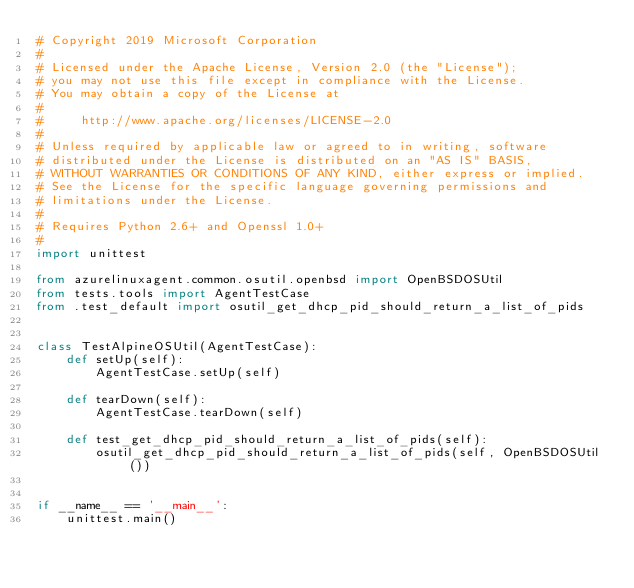<code> <loc_0><loc_0><loc_500><loc_500><_Python_># Copyright 2019 Microsoft Corporation
#
# Licensed under the Apache License, Version 2.0 (the "License");
# you may not use this file except in compliance with the License.
# You may obtain a copy of the License at
#
#     http://www.apache.org/licenses/LICENSE-2.0
#
# Unless required by applicable law or agreed to in writing, software
# distributed under the License is distributed on an "AS IS" BASIS,
# WITHOUT WARRANTIES OR CONDITIONS OF ANY KIND, either express or implied.
# See the License for the specific language governing permissions and
# limitations under the License.
#
# Requires Python 2.6+ and Openssl 1.0+
#
import unittest

from azurelinuxagent.common.osutil.openbsd import OpenBSDOSUtil
from tests.tools import AgentTestCase
from .test_default import osutil_get_dhcp_pid_should_return_a_list_of_pids


class TestAlpineOSUtil(AgentTestCase):
    def setUp(self):
        AgentTestCase.setUp(self)

    def tearDown(self):
        AgentTestCase.tearDown(self)

    def test_get_dhcp_pid_should_return_a_list_of_pids(self):
        osutil_get_dhcp_pid_should_return_a_list_of_pids(self, OpenBSDOSUtil())


if __name__ == '__main__':
    unittest.main()
</code> 